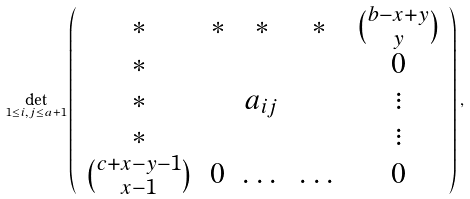Convert formula to latex. <formula><loc_0><loc_0><loc_500><loc_500>\det _ { 1 \leq i , j \leq a + 1 } \left ( \begin{array} { c c c c c } * & * & * & * & \binom { b - x + y } { y } \\ * & & & & 0 \\ * & & a _ { i j } & & \vdots \\ * & & & & \vdots \\ \binom { c + x - y - 1 } { x - 1 } & 0 & \dots & \dots & 0 \end{array} \right ) ,</formula> 